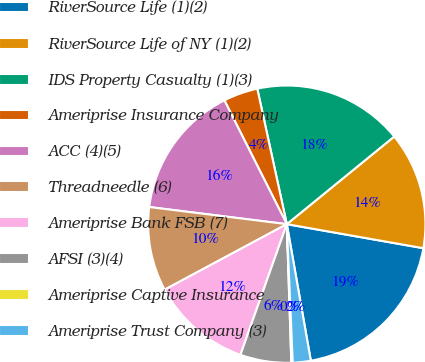<chart> <loc_0><loc_0><loc_500><loc_500><pie_chart><fcel>RiverSource Life (1)(2)<fcel>RiverSource Life of NY (1)(2)<fcel>IDS Property Casualty (1)(3)<fcel>Ameriprise Insurance Company<fcel>ACC (4)(5)<fcel>Threadneedle (6)<fcel>Ameriprise Bank FSB (7)<fcel>AFSI (3)(4)<fcel>Ameriprise Captive Insurance<fcel>Ameriprise Trust Company (3)<nl><fcel>19.46%<fcel>13.67%<fcel>17.53%<fcel>4.02%<fcel>15.6%<fcel>9.81%<fcel>11.74%<fcel>5.95%<fcel>0.16%<fcel>2.09%<nl></chart> 